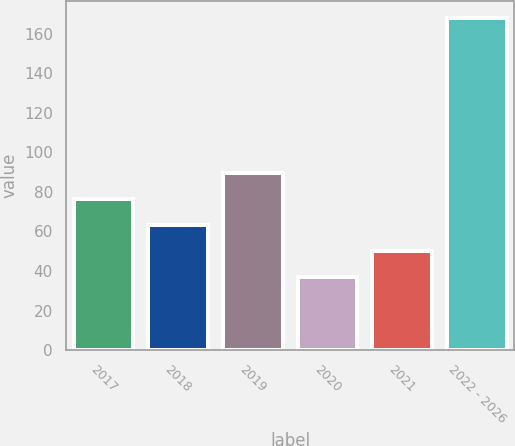Convert chart. <chart><loc_0><loc_0><loc_500><loc_500><bar_chart><fcel>2017<fcel>2018<fcel>2019<fcel>2020<fcel>2021<fcel>2022 - 2026<nl><fcel>76.3<fcel>63.2<fcel>89.4<fcel>37<fcel>50.1<fcel>168<nl></chart> 